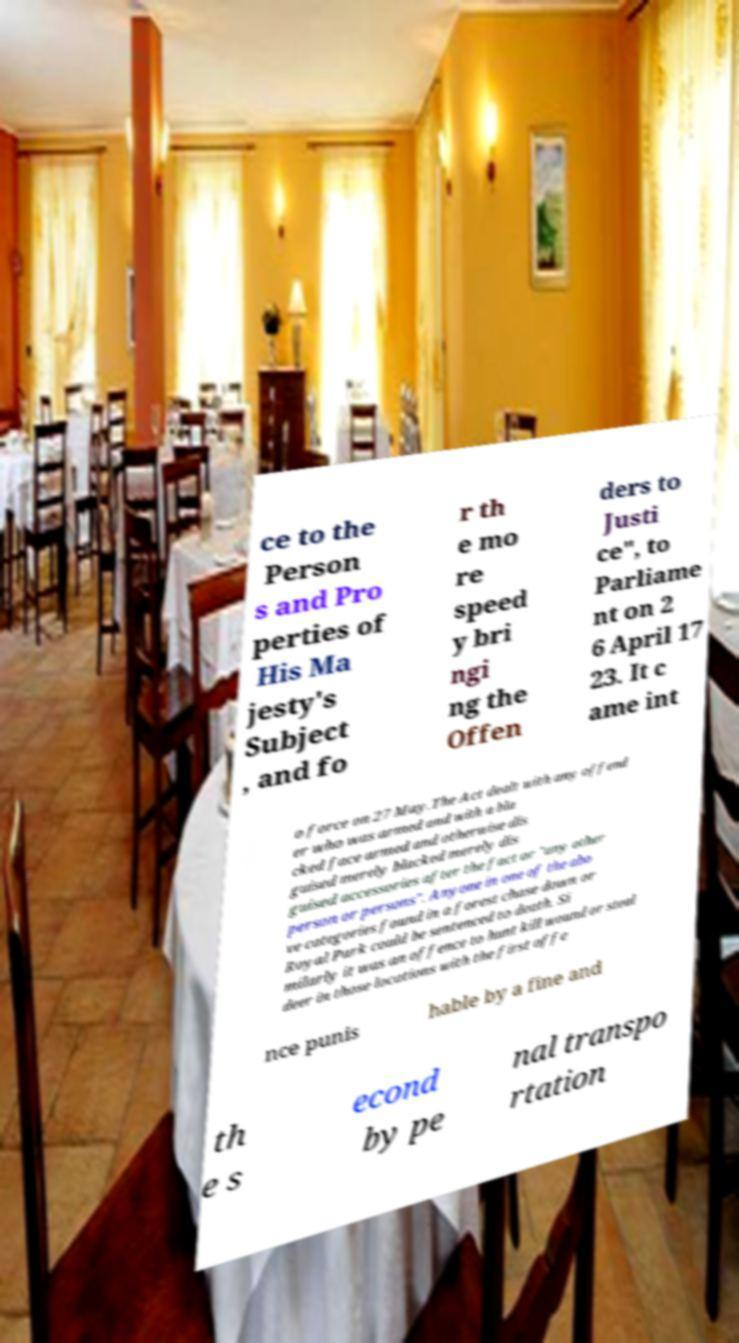Could you assist in decoding the text presented in this image and type it out clearly? ce to the Person s and Pro perties of His Ma jesty's Subject , and fo r th e mo re speed y bri ngi ng the Offen ders to Justi ce", to Parliame nt on 2 6 April 17 23. It c ame int o force on 27 May.The Act dealt with any offend er who was armed and with a bla cked face armed and otherwise dis guised merely blacked merely dis guised accessories after the fact or "any other person or persons". Anyone in one of the abo ve categories found in a forest chase down or Royal Park could be sentenced to death. Si milarly it was an offence to hunt kill wound or steal deer in those locations with the first offe nce punis hable by a fine and th e s econd by pe nal transpo rtation 